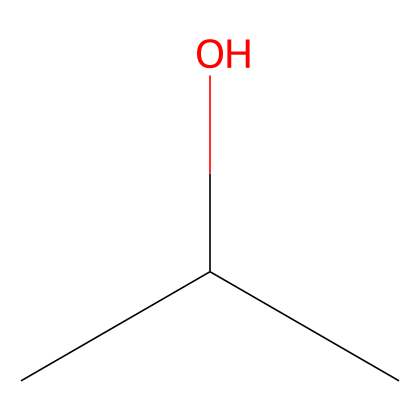What is the primary functional group present in this chemical? The chemical structure of isopropyl alcohol contains a hydroxyl (-OH) group, which is characteristic of alcohols. This group indicates that the substance is indeed an alcohol.
Answer: hydroxyl How many carbon atoms are in isopropyl alcohol? By analyzing the SMILES representation, we can see that there are three carbon atoms connected in the structure, indicating the presence of three carbon atoms in isopropyl alcohol.
Answer: three What type of alcohol is isopropyl alcohol classified as? Isopropyl alcohol has one hydroxyl group attached to a secondary carbon, classifying it as a secondary alcohol.
Answer: secondary alcohol Does isopropyl alcohol have any unsaturation? The structural representation shows that all carbon atoms are single-bonded to each other and to the hydroxyl group, indicating the absence of double or triple bonds, hence no unsaturation is present.
Answer: no How many hydrogen atoms are present in isopropyl alcohol? Each carbon in the structure is bonded to hydrogen atoms to satisfy their tetravalent nature, leading to a total of eight hydrogen atoms associated with the three carbon atoms in isopropyl alcohol.
Answer: eight What physical state is isopropyl alcohol at room temperature? Isopropyl alcohol is commonly known to be a liquid at room temperature due to its molecular composition and interactions between molecules.
Answer: liquid 